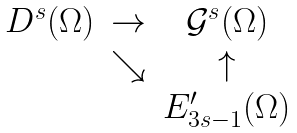<formula> <loc_0><loc_0><loc_500><loc_500>\begin{array} { c c c } D ^ { s } ( \Omega ) & \rightarrow & \mathcal { G } ^ { s } ( \Omega ) \\ & \searrow & \uparrow \\ & & E _ { 3 s - 1 } ^ { \prime } ( \Omega ) \end{array}</formula> 